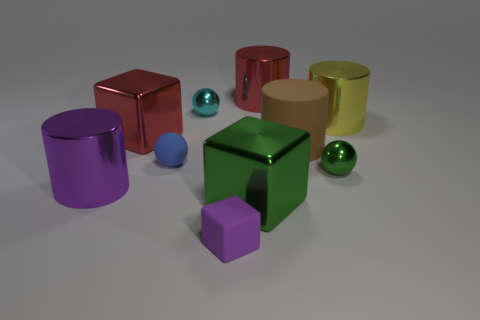Subtract all cylinders. How many objects are left? 6 Add 4 cyan objects. How many cyan objects are left? 5 Add 3 blue spheres. How many blue spheres exist? 4 Subtract 0 gray spheres. How many objects are left? 10 Subtract all big shiny blocks. Subtract all big purple objects. How many objects are left? 7 